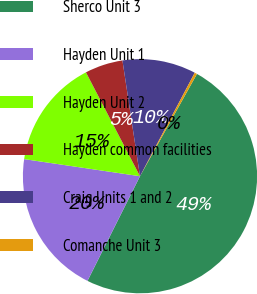Convert chart. <chart><loc_0><loc_0><loc_500><loc_500><pie_chart><fcel>Sherco Unit 3<fcel>Hayden Unit 1<fcel>Hayden Unit 2<fcel>Hayden common facilities<fcel>Craig Units 1 and 2<fcel>Comanche Unit 3<nl><fcel>49.31%<fcel>19.93%<fcel>15.03%<fcel>5.24%<fcel>10.14%<fcel>0.34%<nl></chart> 